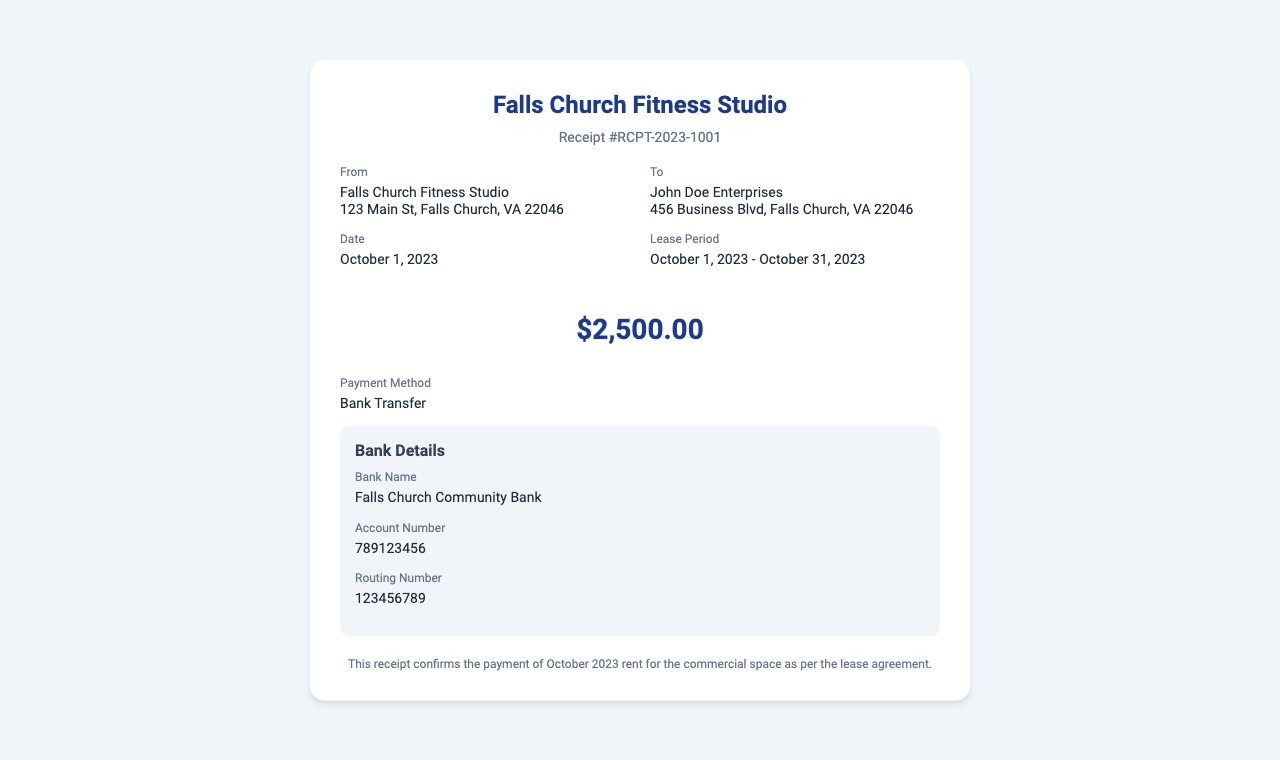What is the rent amount? The rent amount is stated clearly in the document as the total due for the lease period.
Answer: $2,500.00 What is the lease period? The lease period is mentioned explicitly in the details section, indicating the start and end dates of the rental agreement.
Answer: October 1, 2023 - October 31, 2023 Who is the recipient of this receipt? The recipient is identified in the "To" section of the details, which specifies the name and address.
Answer: John Doe Enterprises What is the payment method? The document specifies the method used for this transaction, which is clearly labeled.
Answer: Bank Transfer What date is the receipt issued? The date given in the document marks when the payment was processed as per the receipt.
Answer: October 1, 2023 What is the bank name for the payment? The bank name is listed under the bank details in the receipt section.
Answer: Falls Church Community Bank What is the receipt number? The receipt number is provided at the top of the document for reference to this transaction.
Answer: RCPT-2023-1001 What is the account number? The account number is mentioned in the bank details section for transaction purposes.
Answer: 789123456 